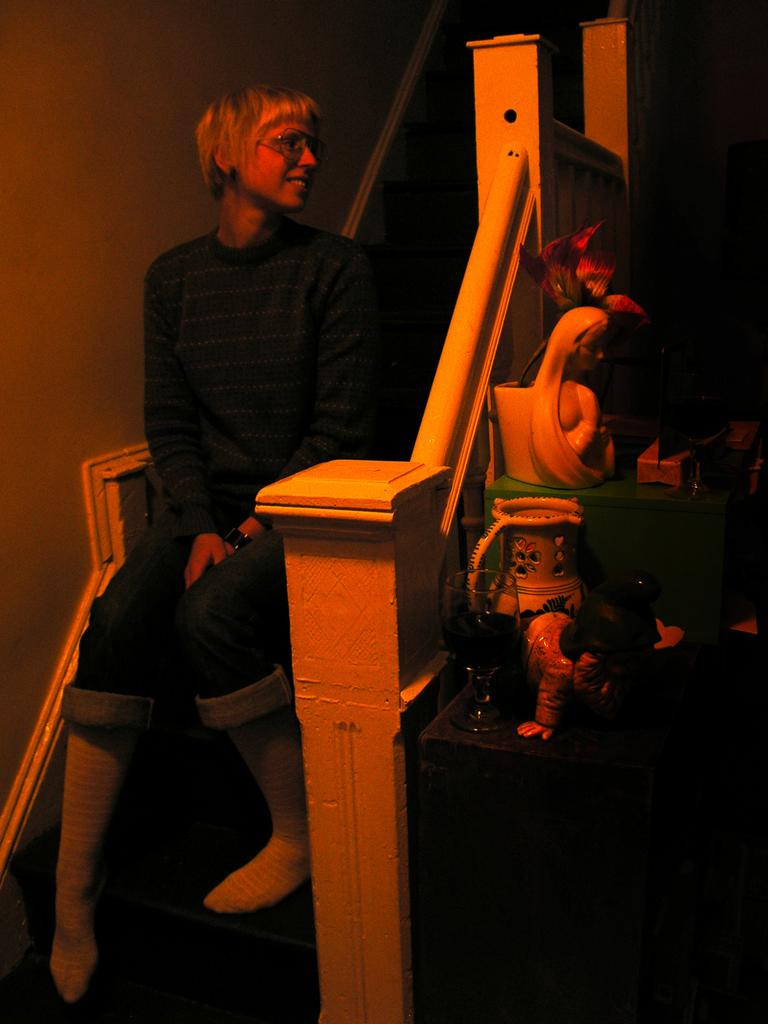What is the person in the image doing? The person is sitting on the stairs. What else can be seen in the image besides the person? There is a statue in the image. How does the kitten contribute to the growth of the statue in the image? There is no kitten present in the image, and therefore it cannot contribute to the growth of the statue. 